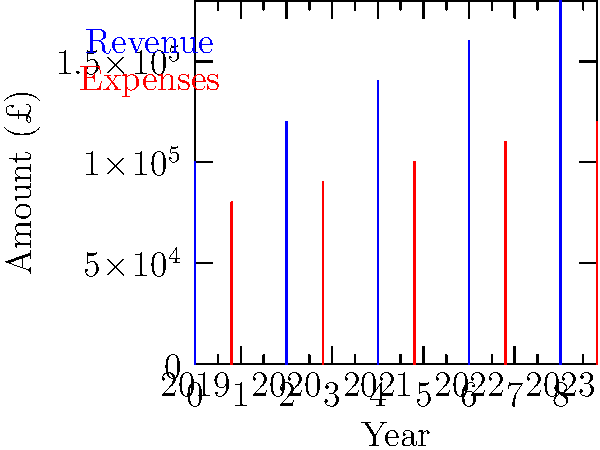As a small business owner, you're reviewing your company's financial performance over the past five years. The bar graph shows your annual revenue and expenses from 2019 to 2023. What was your profit margin percentage in 2023? To calculate the profit margin percentage for 2023, we'll follow these steps:

1. Identify the revenue and expenses for 2023:
   Revenue = £180,000
   Expenses = £120,000

2. Calculate the profit:
   Profit = Revenue - Expenses
   Profit = £180,000 - £120,000 = £60,000

3. Calculate the profit margin percentage:
   Profit Margin % = (Profit / Revenue) × 100
   Profit Margin % = (£60,000 / £180,000) × 100
   Profit Margin % = 0.3333... × 100 = 33.33%

Therefore, the profit margin percentage for 2023 was approximately 33.33%.
Answer: 33.33% 